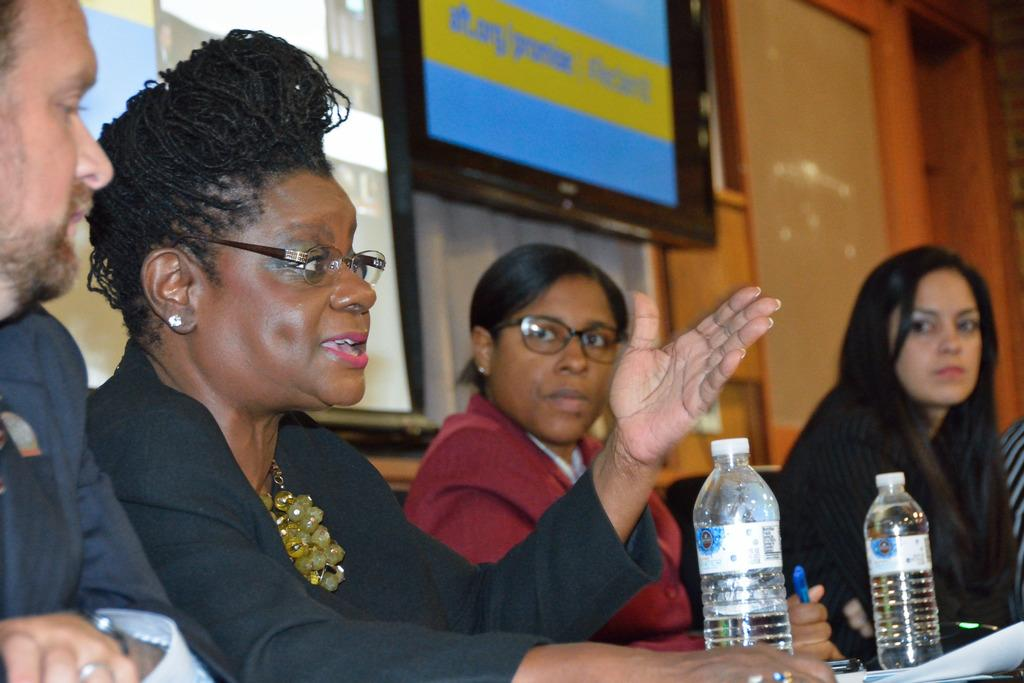How many people are present in the image? There are four people in the image: three women and one man. What are the people doing in the image? The people are sitting on chairs in the image. What objects can be seen in the image besides the people? There are bottles and papers in the image. What is one of the women doing in the image? A woman is talking in the image. What type of tail can be seen on the man in the image? There is no tail present on the man in the image. What sound does the alarm make in the image? There is no alarm present in the image. 